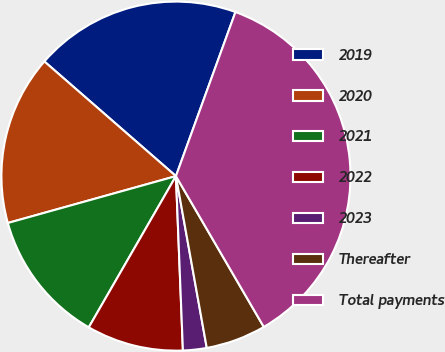<chart> <loc_0><loc_0><loc_500><loc_500><pie_chart><fcel>2019<fcel>2020<fcel>2021<fcel>2022<fcel>2023<fcel>Thereafter<fcel>Total payments<nl><fcel>19.13%<fcel>15.74%<fcel>12.35%<fcel>8.96%<fcel>2.19%<fcel>5.57%<fcel>36.07%<nl></chart> 